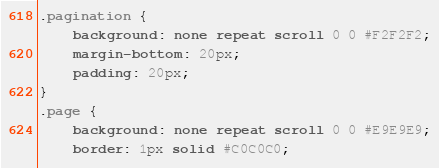<code> <loc_0><loc_0><loc_500><loc_500><_CSS_>.pagination {
    background: none repeat scroll 0 0 #F2F2F2;
    margin-bottom: 20px;
    padding: 20px;
}
.page {
    background: none repeat scroll 0 0 #E9E9E9;
    border: 1px solid #C0C0C0;</code> 